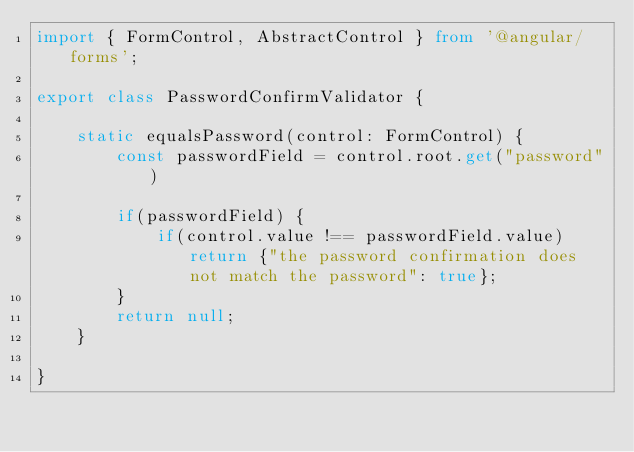<code> <loc_0><loc_0><loc_500><loc_500><_TypeScript_>import { FormControl, AbstractControl } from '@angular/forms';

export class PasswordConfirmValidator {

    static equalsPassword(control: FormControl) {
        const passwordField = control.root.get("password")

        if(passwordField) {
            if(control.value !== passwordField.value) return {"the password confirmation does not match the password": true};
        }
        return null;
    }

}</code> 